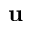Convert formula to latex. <formula><loc_0><loc_0><loc_500><loc_500>u</formula> 